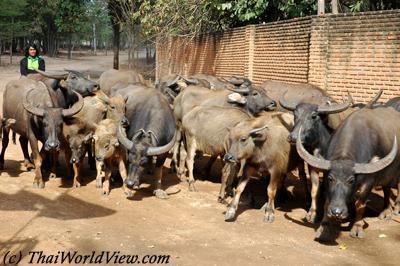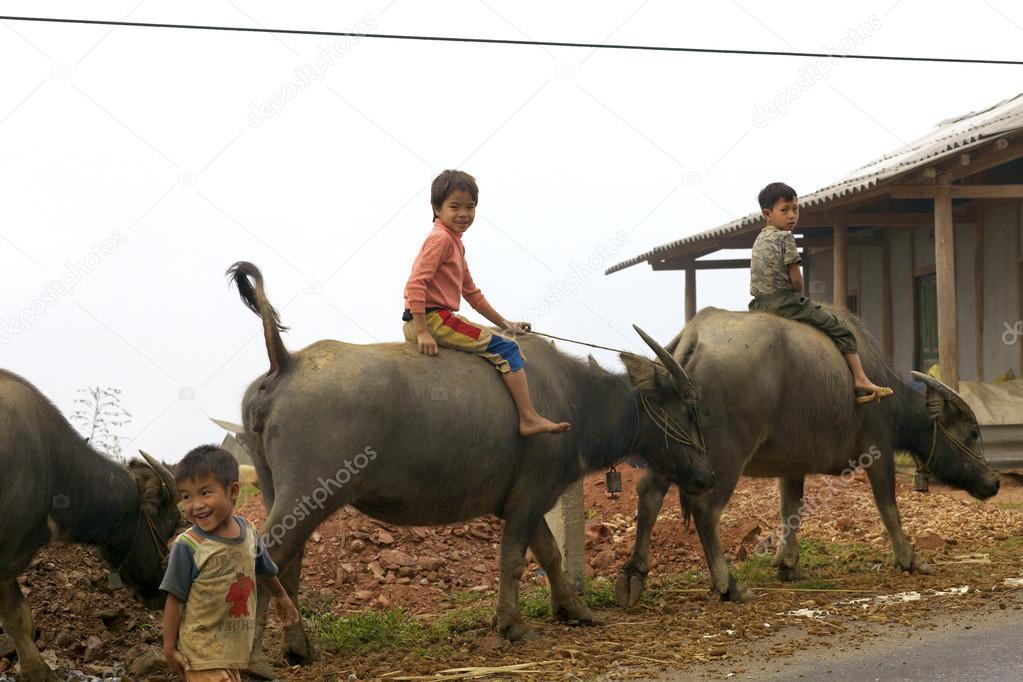The first image is the image on the left, the second image is the image on the right. Considering the images on both sides, is "One image includes a person standing by a water buffalo in a wet area, and the other image shows one person in blue standing by water buffalo on dry ground." valid? Answer yes or no. No. 